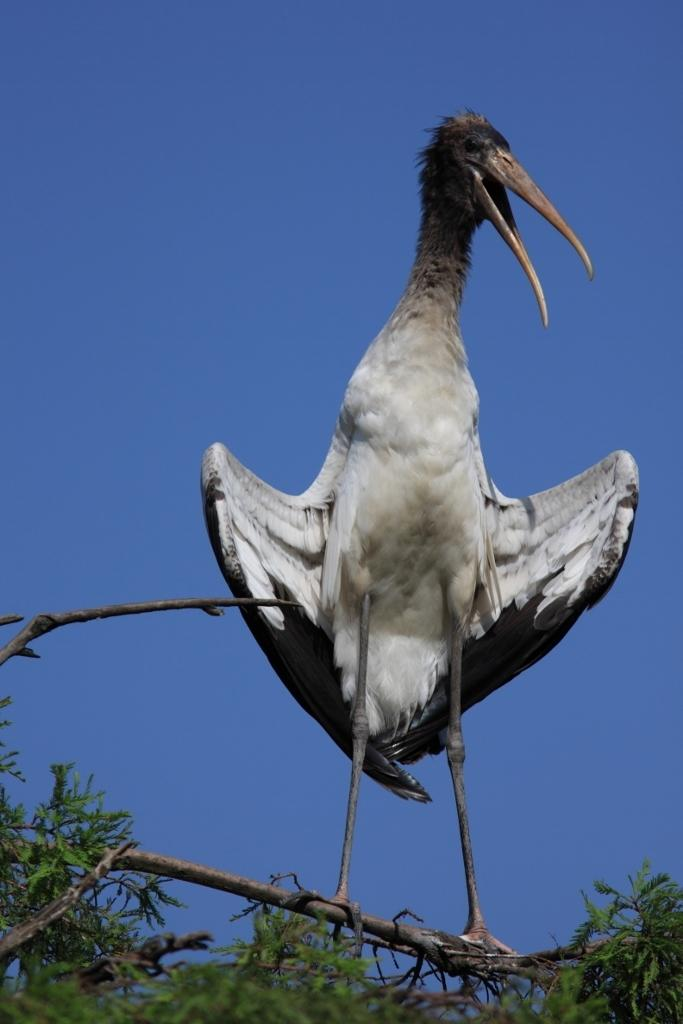What type of vegetation can be seen in the image? There are green color leaves in the image. What part of the trees is visible in the image? There are tree stems in the image. Is there any wildlife present in the image? Yes, a white and black color bird is present on one of the tree stems. What can be seen in the background of the image? The sky is visible in the background of the image. How many chairs are placed around the tree in the image? There are no chairs present in the image. What type of cap is the tree wearing in the image? There is no cap present in the image; it is a tree with leaves and stems. 